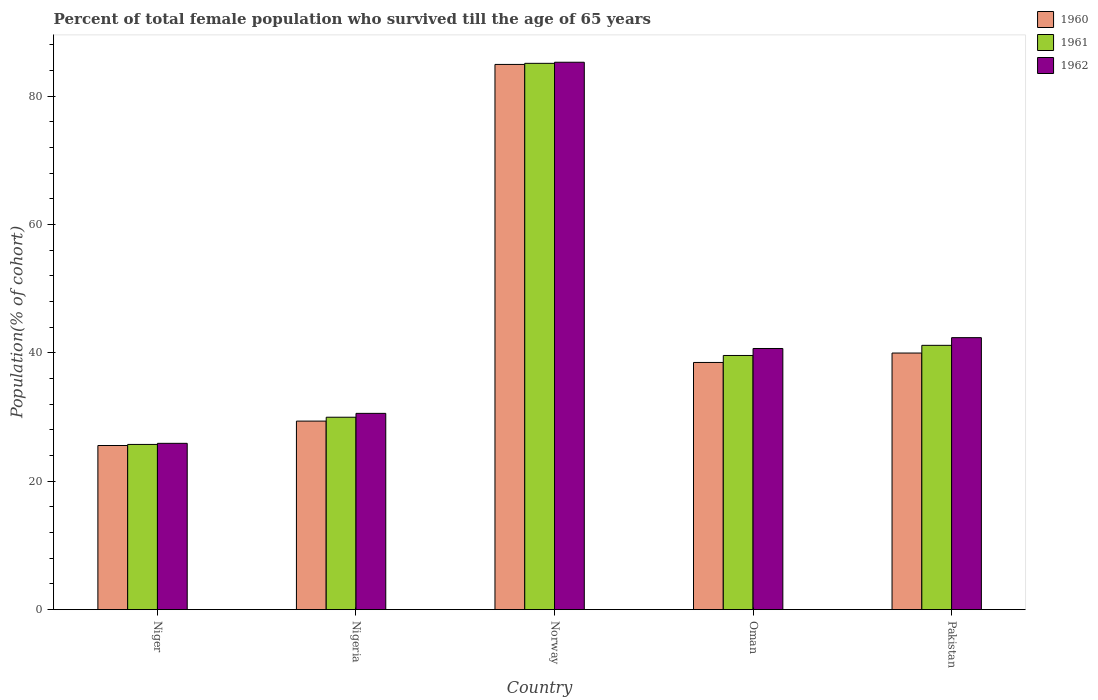How many different coloured bars are there?
Provide a short and direct response. 3. Are the number of bars per tick equal to the number of legend labels?
Give a very brief answer. Yes. How many bars are there on the 1st tick from the right?
Keep it short and to the point. 3. What is the label of the 1st group of bars from the left?
Keep it short and to the point. Niger. What is the percentage of total female population who survived till the age of 65 years in 1960 in Niger?
Offer a very short reply. 25.57. Across all countries, what is the maximum percentage of total female population who survived till the age of 65 years in 1960?
Your answer should be very brief. 84.94. Across all countries, what is the minimum percentage of total female population who survived till the age of 65 years in 1961?
Keep it short and to the point. 25.74. In which country was the percentage of total female population who survived till the age of 65 years in 1962 minimum?
Your response must be concise. Niger. What is the total percentage of total female population who survived till the age of 65 years in 1961 in the graph?
Provide a short and direct response. 221.58. What is the difference between the percentage of total female population who survived till the age of 65 years in 1961 in Niger and that in Norway?
Offer a very short reply. -59.37. What is the difference between the percentage of total female population who survived till the age of 65 years in 1961 in Nigeria and the percentage of total female population who survived till the age of 65 years in 1962 in Norway?
Make the answer very short. -55.3. What is the average percentage of total female population who survived till the age of 65 years in 1962 per country?
Make the answer very short. 44.96. What is the difference between the percentage of total female population who survived till the age of 65 years of/in 1962 and percentage of total female population who survived till the age of 65 years of/in 1961 in Nigeria?
Give a very brief answer. 0.6. What is the ratio of the percentage of total female population who survived till the age of 65 years in 1962 in Norway to that in Oman?
Offer a terse response. 2.1. Is the difference between the percentage of total female population who survived till the age of 65 years in 1962 in Norway and Oman greater than the difference between the percentage of total female population who survived till the age of 65 years in 1961 in Norway and Oman?
Offer a very short reply. No. What is the difference between the highest and the second highest percentage of total female population who survived till the age of 65 years in 1961?
Your answer should be compact. -43.93. What is the difference between the highest and the lowest percentage of total female population who survived till the age of 65 years in 1960?
Provide a short and direct response. 59.37. Is the sum of the percentage of total female population who survived till the age of 65 years in 1962 in Niger and Pakistan greater than the maximum percentage of total female population who survived till the age of 65 years in 1960 across all countries?
Offer a very short reply. No. What does the 3rd bar from the left in Pakistan represents?
Offer a very short reply. 1962. What does the 3rd bar from the right in Nigeria represents?
Your response must be concise. 1960. Are all the bars in the graph horizontal?
Provide a short and direct response. No. Are the values on the major ticks of Y-axis written in scientific E-notation?
Ensure brevity in your answer.  No. Does the graph contain any zero values?
Your response must be concise. No. How many legend labels are there?
Provide a succinct answer. 3. What is the title of the graph?
Make the answer very short. Percent of total female population who survived till the age of 65 years. What is the label or title of the Y-axis?
Keep it short and to the point. Population(% of cohort). What is the Population(% of cohort) of 1960 in Niger?
Offer a very short reply. 25.57. What is the Population(% of cohort) in 1961 in Niger?
Provide a short and direct response. 25.74. What is the Population(% of cohort) in 1962 in Niger?
Provide a short and direct response. 25.91. What is the Population(% of cohort) in 1960 in Nigeria?
Your response must be concise. 29.37. What is the Population(% of cohort) of 1961 in Nigeria?
Make the answer very short. 29.97. What is the Population(% of cohort) of 1962 in Nigeria?
Ensure brevity in your answer.  30.58. What is the Population(% of cohort) of 1960 in Norway?
Offer a very short reply. 84.94. What is the Population(% of cohort) in 1961 in Norway?
Offer a terse response. 85.11. What is the Population(% of cohort) in 1962 in Norway?
Your response must be concise. 85.28. What is the Population(% of cohort) of 1960 in Oman?
Offer a terse response. 38.5. What is the Population(% of cohort) in 1961 in Oman?
Offer a terse response. 39.59. What is the Population(% of cohort) of 1962 in Oman?
Provide a short and direct response. 40.68. What is the Population(% of cohort) in 1960 in Pakistan?
Provide a succinct answer. 39.97. What is the Population(% of cohort) of 1961 in Pakistan?
Provide a succinct answer. 41.17. What is the Population(% of cohort) in 1962 in Pakistan?
Your response must be concise. 42.37. Across all countries, what is the maximum Population(% of cohort) of 1960?
Offer a very short reply. 84.94. Across all countries, what is the maximum Population(% of cohort) of 1961?
Your answer should be very brief. 85.11. Across all countries, what is the maximum Population(% of cohort) of 1962?
Your answer should be very brief. 85.28. Across all countries, what is the minimum Population(% of cohort) of 1960?
Your response must be concise. 25.57. Across all countries, what is the minimum Population(% of cohort) in 1961?
Provide a succinct answer. 25.74. Across all countries, what is the minimum Population(% of cohort) in 1962?
Provide a short and direct response. 25.91. What is the total Population(% of cohort) in 1960 in the graph?
Your response must be concise. 218.35. What is the total Population(% of cohort) of 1961 in the graph?
Your response must be concise. 221.58. What is the total Population(% of cohort) in 1962 in the graph?
Make the answer very short. 224.81. What is the difference between the Population(% of cohort) in 1960 in Niger and that in Nigeria?
Provide a short and direct response. -3.8. What is the difference between the Population(% of cohort) in 1961 in Niger and that in Nigeria?
Make the answer very short. -4.24. What is the difference between the Population(% of cohort) of 1962 in Niger and that in Nigeria?
Your answer should be very brief. -4.67. What is the difference between the Population(% of cohort) of 1960 in Niger and that in Norway?
Make the answer very short. -59.37. What is the difference between the Population(% of cohort) in 1961 in Niger and that in Norway?
Offer a terse response. -59.37. What is the difference between the Population(% of cohort) of 1962 in Niger and that in Norway?
Provide a succinct answer. -59.37. What is the difference between the Population(% of cohort) in 1960 in Niger and that in Oman?
Keep it short and to the point. -12.94. What is the difference between the Population(% of cohort) in 1961 in Niger and that in Oman?
Offer a terse response. -13.86. What is the difference between the Population(% of cohort) of 1962 in Niger and that in Oman?
Your response must be concise. -14.78. What is the difference between the Population(% of cohort) in 1960 in Niger and that in Pakistan?
Ensure brevity in your answer.  -14.41. What is the difference between the Population(% of cohort) of 1961 in Niger and that in Pakistan?
Offer a terse response. -15.44. What is the difference between the Population(% of cohort) of 1962 in Niger and that in Pakistan?
Provide a short and direct response. -16.47. What is the difference between the Population(% of cohort) of 1960 in Nigeria and that in Norway?
Give a very brief answer. -55.57. What is the difference between the Population(% of cohort) of 1961 in Nigeria and that in Norway?
Keep it short and to the point. -55.13. What is the difference between the Population(% of cohort) in 1962 in Nigeria and that in Norway?
Your response must be concise. -54.7. What is the difference between the Population(% of cohort) of 1960 in Nigeria and that in Oman?
Offer a terse response. -9.13. What is the difference between the Population(% of cohort) of 1961 in Nigeria and that in Oman?
Provide a succinct answer. -9.62. What is the difference between the Population(% of cohort) of 1962 in Nigeria and that in Oman?
Provide a short and direct response. -10.1. What is the difference between the Population(% of cohort) of 1960 in Nigeria and that in Pakistan?
Make the answer very short. -10.6. What is the difference between the Population(% of cohort) of 1961 in Nigeria and that in Pakistan?
Keep it short and to the point. -11.2. What is the difference between the Population(% of cohort) in 1962 in Nigeria and that in Pakistan?
Offer a very short reply. -11.8. What is the difference between the Population(% of cohort) of 1960 in Norway and that in Oman?
Keep it short and to the point. 46.43. What is the difference between the Population(% of cohort) in 1961 in Norway and that in Oman?
Provide a succinct answer. 45.51. What is the difference between the Population(% of cohort) of 1962 in Norway and that in Oman?
Offer a very short reply. 44.59. What is the difference between the Population(% of cohort) of 1960 in Norway and that in Pakistan?
Make the answer very short. 44.96. What is the difference between the Population(% of cohort) of 1961 in Norway and that in Pakistan?
Give a very brief answer. 43.93. What is the difference between the Population(% of cohort) of 1962 in Norway and that in Pakistan?
Your response must be concise. 42.9. What is the difference between the Population(% of cohort) in 1960 in Oman and that in Pakistan?
Make the answer very short. -1.47. What is the difference between the Population(% of cohort) in 1961 in Oman and that in Pakistan?
Provide a succinct answer. -1.58. What is the difference between the Population(% of cohort) of 1962 in Oman and that in Pakistan?
Your response must be concise. -1.69. What is the difference between the Population(% of cohort) in 1960 in Niger and the Population(% of cohort) in 1961 in Nigeria?
Your answer should be compact. -4.41. What is the difference between the Population(% of cohort) of 1960 in Niger and the Population(% of cohort) of 1962 in Nigeria?
Keep it short and to the point. -5.01. What is the difference between the Population(% of cohort) in 1961 in Niger and the Population(% of cohort) in 1962 in Nigeria?
Provide a short and direct response. -4.84. What is the difference between the Population(% of cohort) in 1960 in Niger and the Population(% of cohort) in 1961 in Norway?
Offer a terse response. -59.54. What is the difference between the Population(% of cohort) in 1960 in Niger and the Population(% of cohort) in 1962 in Norway?
Your answer should be very brief. -59.71. What is the difference between the Population(% of cohort) in 1961 in Niger and the Population(% of cohort) in 1962 in Norway?
Your answer should be compact. -59.54. What is the difference between the Population(% of cohort) of 1960 in Niger and the Population(% of cohort) of 1961 in Oman?
Provide a succinct answer. -14.03. What is the difference between the Population(% of cohort) in 1960 in Niger and the Population(% of cohort) in 1962 in Oman?
Your answer should be compact. -15.11. What is the difference between the Population(% of cohort) in 1961 in Niger and the Population(% of cohort) in 1962 in Oman?
Provide a succinct answer. -14.94. What is the difference between the Population(% of cohort) in 1960 in Niger and the Population(% of cohort) in 1961 in Pakistan?
Keep it short and to the point. -15.6. What is the difference between the Population(% of cohort) of 1960 in Niger and the Population(% of cohort) of 1962 in Pakistan?
Your response must be concise. -16.8. What is the difference between the Population(% of cohort) of 1961 in Niger and the Population(% of cohort) of 1962 in Pakistan?
Your response must be concise. -16.63. What is the difference between the Population(% of cohort) of 1960 in Nigeria and the Population(% of cohort) of 1961 in Norway?
Offer a terse response. -55.73. What is the difference between the Population(% of cohort) in 1960 in Nigeria and the Population(% of cohort) in 1962 in Norway?
Offer a very short reply. -55.9. What is the difference between the Population(% of cohort) of 1961 in Nigeria and the Population(% of cohort) of 1962 in Norway?
Ensure brevity in your answer.  -55.3. What is the difference between the Population(% of cohort) of 1960 in Nigeria and the Population(% of cohort) of 1961 in Oman?
Offer a terse response. -10.22. What is the difference between the Population(% of cohort) in 1960 in Nigeria and the Population(% of cohort) in 1962 in Oman?
Your answer should be compact. -11.31. What is the difference between the Population(% of cohort) of 1961 in Nigeria and the Population(% of cohort) of 1962 in Oman?
Your response must be concise. -10.71. What is the difference between the Population(% of cohort) in 1960 in Nigeria and the Population(% of cohort) in 1961 in Pakistan?
Ensure brevity in your answer.  -11.8. What is the difference between the Population(% of cohort) of 1960 in Nigeria and the Population(% of cohort) of 1962 in Pakistan?
Your answer should be compact. -13. What is the difference between the Population(% of cohort) of 1961 in Nigeria and the Population(% of cohort) of 1962 in Pakistan?
Provide a succinct answer. -12.4. What is the difference between the Population(% of cohort) in 1960 in Norway and the Population(% of cohort) in 1961 in Oman?
Your answer should be very brief. 45.34. What is the difference between the Population(% of cohort) of 1960 in Norway and the Population(% of cohort) of 1962 in Oman?
Offer a terse response. 44.25. What is the difference between the Population(% of cohort) of 1961 in Norway and the Population(% of cohort) of 1962 in Oman?
Offer a very short reply. 44.42. What is the difference between the Population(% of cohort) in 1960 in Norway and the Population(% of cohort) in 1961 in Pakistan?
Make the answer very short. 43.76. What is the difference between the Population(% of cohort) in 1960 in Norway and the Population(% of cohort) in 1962 in Pakistan?
Provide a succinct answer. 42.56. What is the difference between the Population(% of cohort) in 1961 in Norway and the Population(% of cohort) in 1962 in Pakistan?
Make the answer very short. 42.73. What is the difference between the Population(% of cohort) in 1960 in Oman and the Population(% of cohort) in 1961 in Pakistan?
Ensure brevity in your answer.  -2.67. What is the difference between the Population(% of cohort) of 1960 in Oman and the Population(% of cohort) of 1962 in Pakistan?
Ensure brevity in your answer.  -3.87. What is the difference between the Population(% of cohort) in 1961 in Oman and the Population(% of cohort) in 1962 in Pakistan?
Ensure brevity in your answer.  -2.78. What is the average Population(% of cohort) of 1960 per country?
Provide a short and direct response. 43.67. What is the average Population(% of cohort) of 1961 per country?
Give a very brief answer. 44.32. What is the average Population(% of cohort) of 1962 per country?
Provide a short and direct response. 44.96. What is the difference between the Population(% of cohort) of 1960 and Population(% of cohort) of 1961 in Niger?
Give a very brief answer. -0.17. What is the difference between the Population(% of cohort) in 1960 and Population(% of cohort) in 1962 in Niger?
Keep it short and to the point. -0.34. What is the difference between the Population(% of cohort) of 1961 and Population(% of cohort) of 1962 in Niger?
Offer a very short reply. -0.17. What is the difference between the Population(% of cohort) in 1960 and Population(% of cohort) in 1961 in Nigeria?
Ensure brevity in your answer.  -0.6. What is the difference between the Population(% of cohort) in 1960 and Population(% of cohort) in 1962 in Nigeria?
Give a very brief answer. -1.21. What is the difference between the Population(% of cohort) of 1961 and Population(% of cohort) of 1962 in Nigeria?
Give a very brief answer. -0.6. What is the difference between the Population(% of cohort) in 1960 and Population(% of cohort) in 1961 in Norway?
Your response must be concise. -0.17. What is the difference between the Population(% of cohort) in 1960 and Population(% of cohort) in 1962 in Norway?
Keep it short and to the point. -0.34. What is the difference between the Population(% of cohort) of 1961 and Population(% of cohort) of 1962 in Norway?
Offer a very short reply. -0.17. What is the difference between the Population(% of cohort) in 1960 and Population(% of cohort) in 1961 in Oman?
Make the answer very short. -1.09. What is the difference between the Population(% of cohort) of 1960 and Population(% of cohort) of 1962 in Oman?
Ensure brevity in your answer.  -2.18. What is the difference between the Population(% of cohort) in 1961 and Population(% of cohort) in 1962 in Oman?
Provide a short and direct response. -1.09. What is the difference between the Population(% of cohort) in 1960 and Population(% of cohort) in 1961 in Pakistan?
Offer a terse response. -1.2. What is the difference between the Population(% of cohort) of 1960 and Population(% of cohort) of 1962 in Pakistan?
Give a very brief answer. -2.4. What is the difference between the Population(% of cohort) of 1961 and Population(% of cohort) of 1962 in Pakistan?
Make the answer very short. -1.2. What is the ratio of the Population(% of cohort) of 1960 in Niger to that in Nigeria?
Offer a terse response. 0.87. What is the ratio of the Population(% of cohort) of 1961 in Niger to that in Nigeria?
Ensure brevity in your answer.  0.86. What is the ratio of the Population(% of cohort) of 1962 in Niger to that in Nigeria?
Your answer should be compact. 0.85. What is the ratio of the Population(% of cohort) in 1960 in Niger to that in Norway?
Your answer should be very brief. 0.3. What is the ratio of the Population(% of cohort) in 1961 in Niger to that in Norway?
Provide a short and direct response. 0.3. What is the ratio of the Population(% of cohort) of 1962 in Niger to that in Norway?
Your answer should be very brief. 0.3. What is the ratio of the Population(% of cohort) of 1960 in Niger to that in Oman?
Provide a succinct answer. 0.66. What is the ratio of the Population(% of cohort) of 1961 in Niger to that in Oman?
Your response must be concise. 0.65. What is the ratio of the Population(% of cohort) in 1962 in Niger to that in Oman?
Provide a short and direct response. 0.64. What is the ratio of the Population(% of cohort) in 1960 in Niger to that in Pakistan?
Ensure brevity in your answer.  0.64. What is the ratio of the Population(% of cohort) of 1961 in Niger to that in Pakistan?
Ensure brevity in your answer.  0.63. What is the ratio of the Population(% of cohort) in 1962 in Niger to that in Pakistan?
Your response must be concise. 0.61. What is the ratio of the Population(% of cohort) in 1960 in Nigeria to that in Norway?
Offer a very short reply. 0.35. What is the ratio of the Population(% of cohort) in 1961 in Nigeria to that in Norway?
Provide a short and direct response. 0.35. What is the ratio of the Population(% of cohort) of 1962 in Nigeria to that in Norway?
Your answer should be very brief. 0.36. What is the ratio of the Population(% of cohort) of 1960 in Nigeria to that in Oman?
Keep it short and to the point. 0.76. What is the ratio of the Population(% of cohort) of 1961 in Nigeria to that in Oman?
Offer a very short reply. 0.76. What is the ratio of the Population(% of cohort) in 1962 in Nigeria to that in Oman?
Offer a terse response. 0.75. What is the ratio of the Population(% of cohort) in 1960 in Nigeria to that in Pakistan?
Offer a terse response. 0.73. What is the ratio of the Population(% of cohort) in 1961 in Nigeria to that in Pakistan?
Ensure brevity in your answer.  0.73. What is the ratio of the Population(% of cohort) of 1962 in Nigeria to that in Pakistan?
Offer a very short reply. 0.72. What is the ratio of the Population(% of cohort) in 1960 in Norway to that in Oman?
Your answer should be compact. 2.21. What is the ratio of the Population(% of cohort) in 1961 in Norway to that in Oman?
Offer a very short reply. 2.15. What is the ratio of the Population(% of cohort) in 1962 in Norway to that in Oman?
Offer a terse response. 2.1. What is the ratio of the Population(% of cohort) in 1960 in Norway to that in Pakistan?
Ensure brevity in your answer.  2.12. What is the ratio of the Population(% of cohort) in 1961 in Norway to that in Pakistan?
Offer a terse response. 2.07. What is the ratio of the Population(% of cohort) in 1962 in Norway to that in Pakistan?
Ensure brevity in your answer.  2.01. What is the ratio of the Population(% of cohort) in 1960 in Oman to that in Pakistan?
Your answer should be very brief. 0.96. What is the ratio of the Population(% of cohort) in 1961 in Oman to that in Pakistan?
Make the answer very short. 0.96. What is the ratio of the Population(% of cohort) of 1962 in Oman to that in Pakistan?
Make the answer very short. 0.96. What is the difference between the highest and the second highest Population(% of cohort) of 1960?
Ensure brevity in your answer.  44.96. What is the difference between the highest and the second highest Population(% of cohort) in 1961?
Offer a terse response. 43.93. What is the difference between the highest and the second highest Population(% of cohort) of 1962?
Your answer should be very brief. 42.9. What is the difference between the highest and the lowest Population(% of cohort) in 1960?
Your answer should be very brief. 59.37. What is the difference between the highest and the lowest Population(% of cohort) of 1961?
Offer a very short reply. 59.37. What is the difference between the highest and the lowest Population(% of cohort) of 1962?
Your response must be concise. 59.37. 